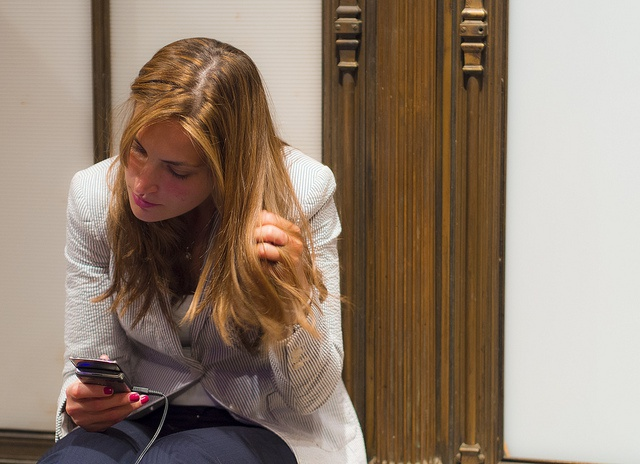Describe the objects in this image and their specific colors. I can see people in darkgray, black, maroon, and gray tones and cell phone in darkgray, black, maroon, gray, and brown tones in this image. 